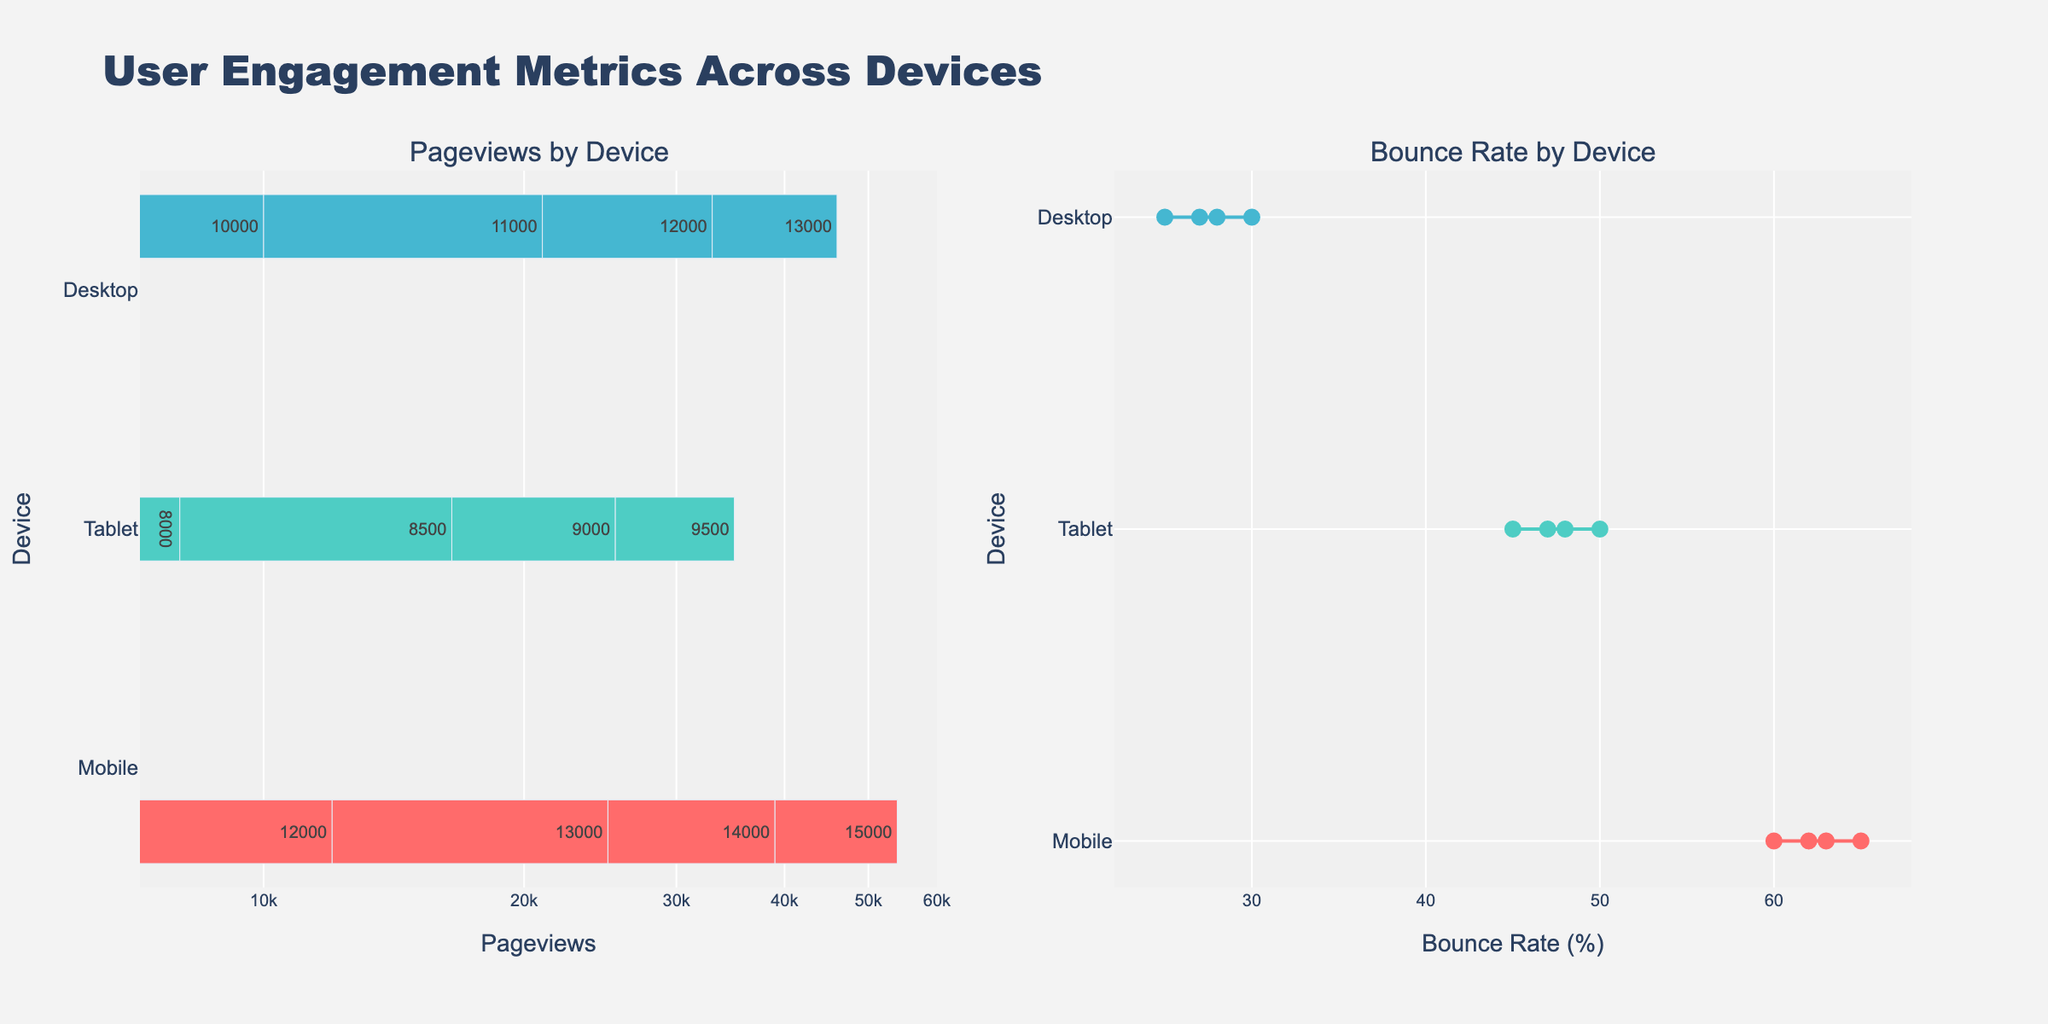How many devices are represented in the plot? The bar subplot shows different colors representing different devices, and there are three unique hues. The title and data labels indicate 'Mobile,' 'Tablet,' and 'Desktop.'
Answer: Three Which device has the highest pageviews? By observing the left subplot, the longest bars represent the highest pageviews. The 'Mobile' device has the longest bars reaching up to 15,000 pageviews.
Answer: Mobile What is the bounce rate range for tablets? In the right subplot, locate the points and lines for 'Tablet.' The bounce rate points vary from 45% to 50%.
Answer: 45% to 50% Between tablets and desktops, which has a lower overall bounce rate? Compare the blue ('Desktop') and teal ('Tablet') lines and points on the right subplot. 'Desktop' bounce rates are lower, ranging from 25% to 30%, while tablets range from 45% to 50%.
Answer: Desktop What's the title of the figure? Observe the top center of the figure where the main title is located. It reads "User Engagement Metrics Across Devices."
Answer: User Engagement Metrics Across Devices How does the bounce rate for mobile devices trend as pageviews increase? Examine the red markers and line in the right subplot. As pageviews increase from 12,000 to 15,000, the bounce rate for mobile devices decreases from 65% to 60%.
Answer: Decreases Comparing pageviews, which device type has the most spread—mobile, tablet, or desktop? Look at the range in the left subplot. 'Mobile' spans from 12,000 to 15,000; 'Tablet' from 8,000 to 9,500; 'Desktop' from 10,000 to 13,000. 'Mobile' shows the widest range.
Answer: Mobile In log-scale, how do the bar lengths compare between mobile and desktop for the highest pageviews? For the left subplot, even though the bar lengths differ visually, in log scale, higher values have compressed spacing. 'Mobile' has a longer bar than 'Desktop,' indicating it has more pageviews when compared logaritmically.
Answer: Mobile has more What is the average bounce rate for desktop devices? Identify the bounce rate values for desktops: 25, 27, 28, and 30. Sum these values and divide by the count: (25 + 27 + 28 + 30) / 4 = 27.5%.
Answer: 27.5% Is there any device type that shows an upward trend in bounce rate? Observe the line plots in the right subplot. None of the lines show an upward trajectory; all device types exhibit a downward trend in bounce rates as pageviews increase.
Answer: No 